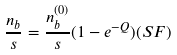<formula> <loc_0><loc_0><loc_500><loc_500>\frac { n _ { b } } { s } = \frac { n _ { b } ^ { ( 0 ) } } { s } ( 1 - e ^ { - Q } ) ( S F )</formula> 